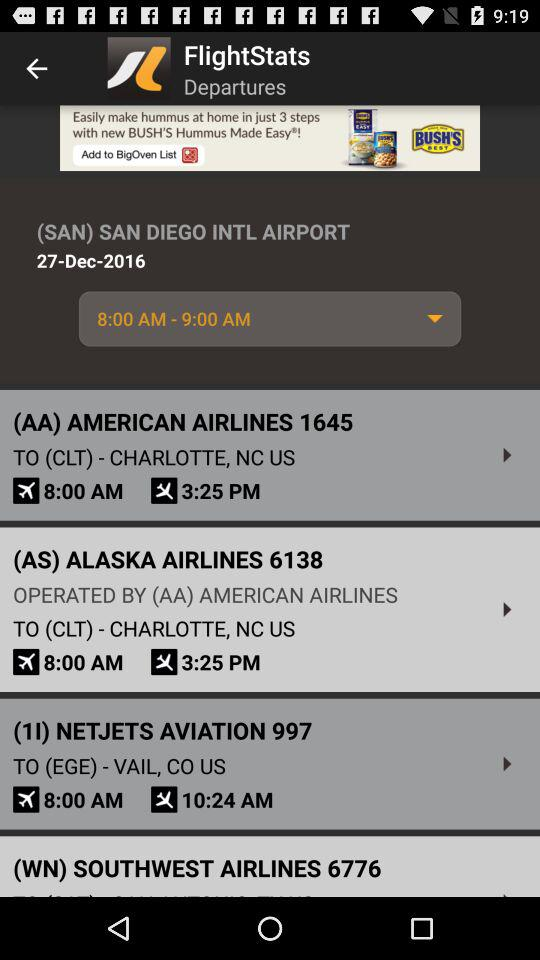How many flights are there for the departure airport of SAN?
Answer the question using a single word or phrase. 3 